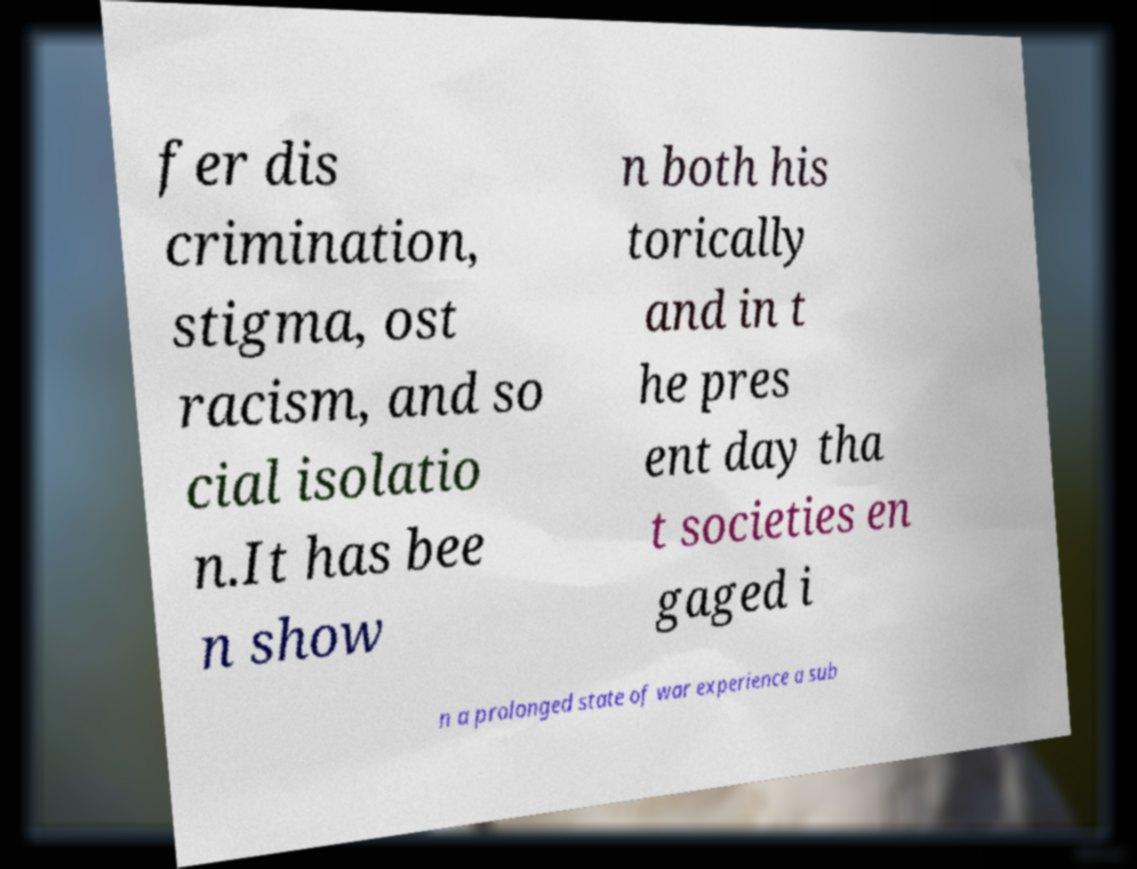Could you assist in decoding the text presented in this image and type it out clearly? fer dis crimination, stigma, ost racism, and so cial isolatio n.It has bee n show n both his torically and in t he pres ent day tha t societies en gaged i n a prolonged state of war experience a sub 